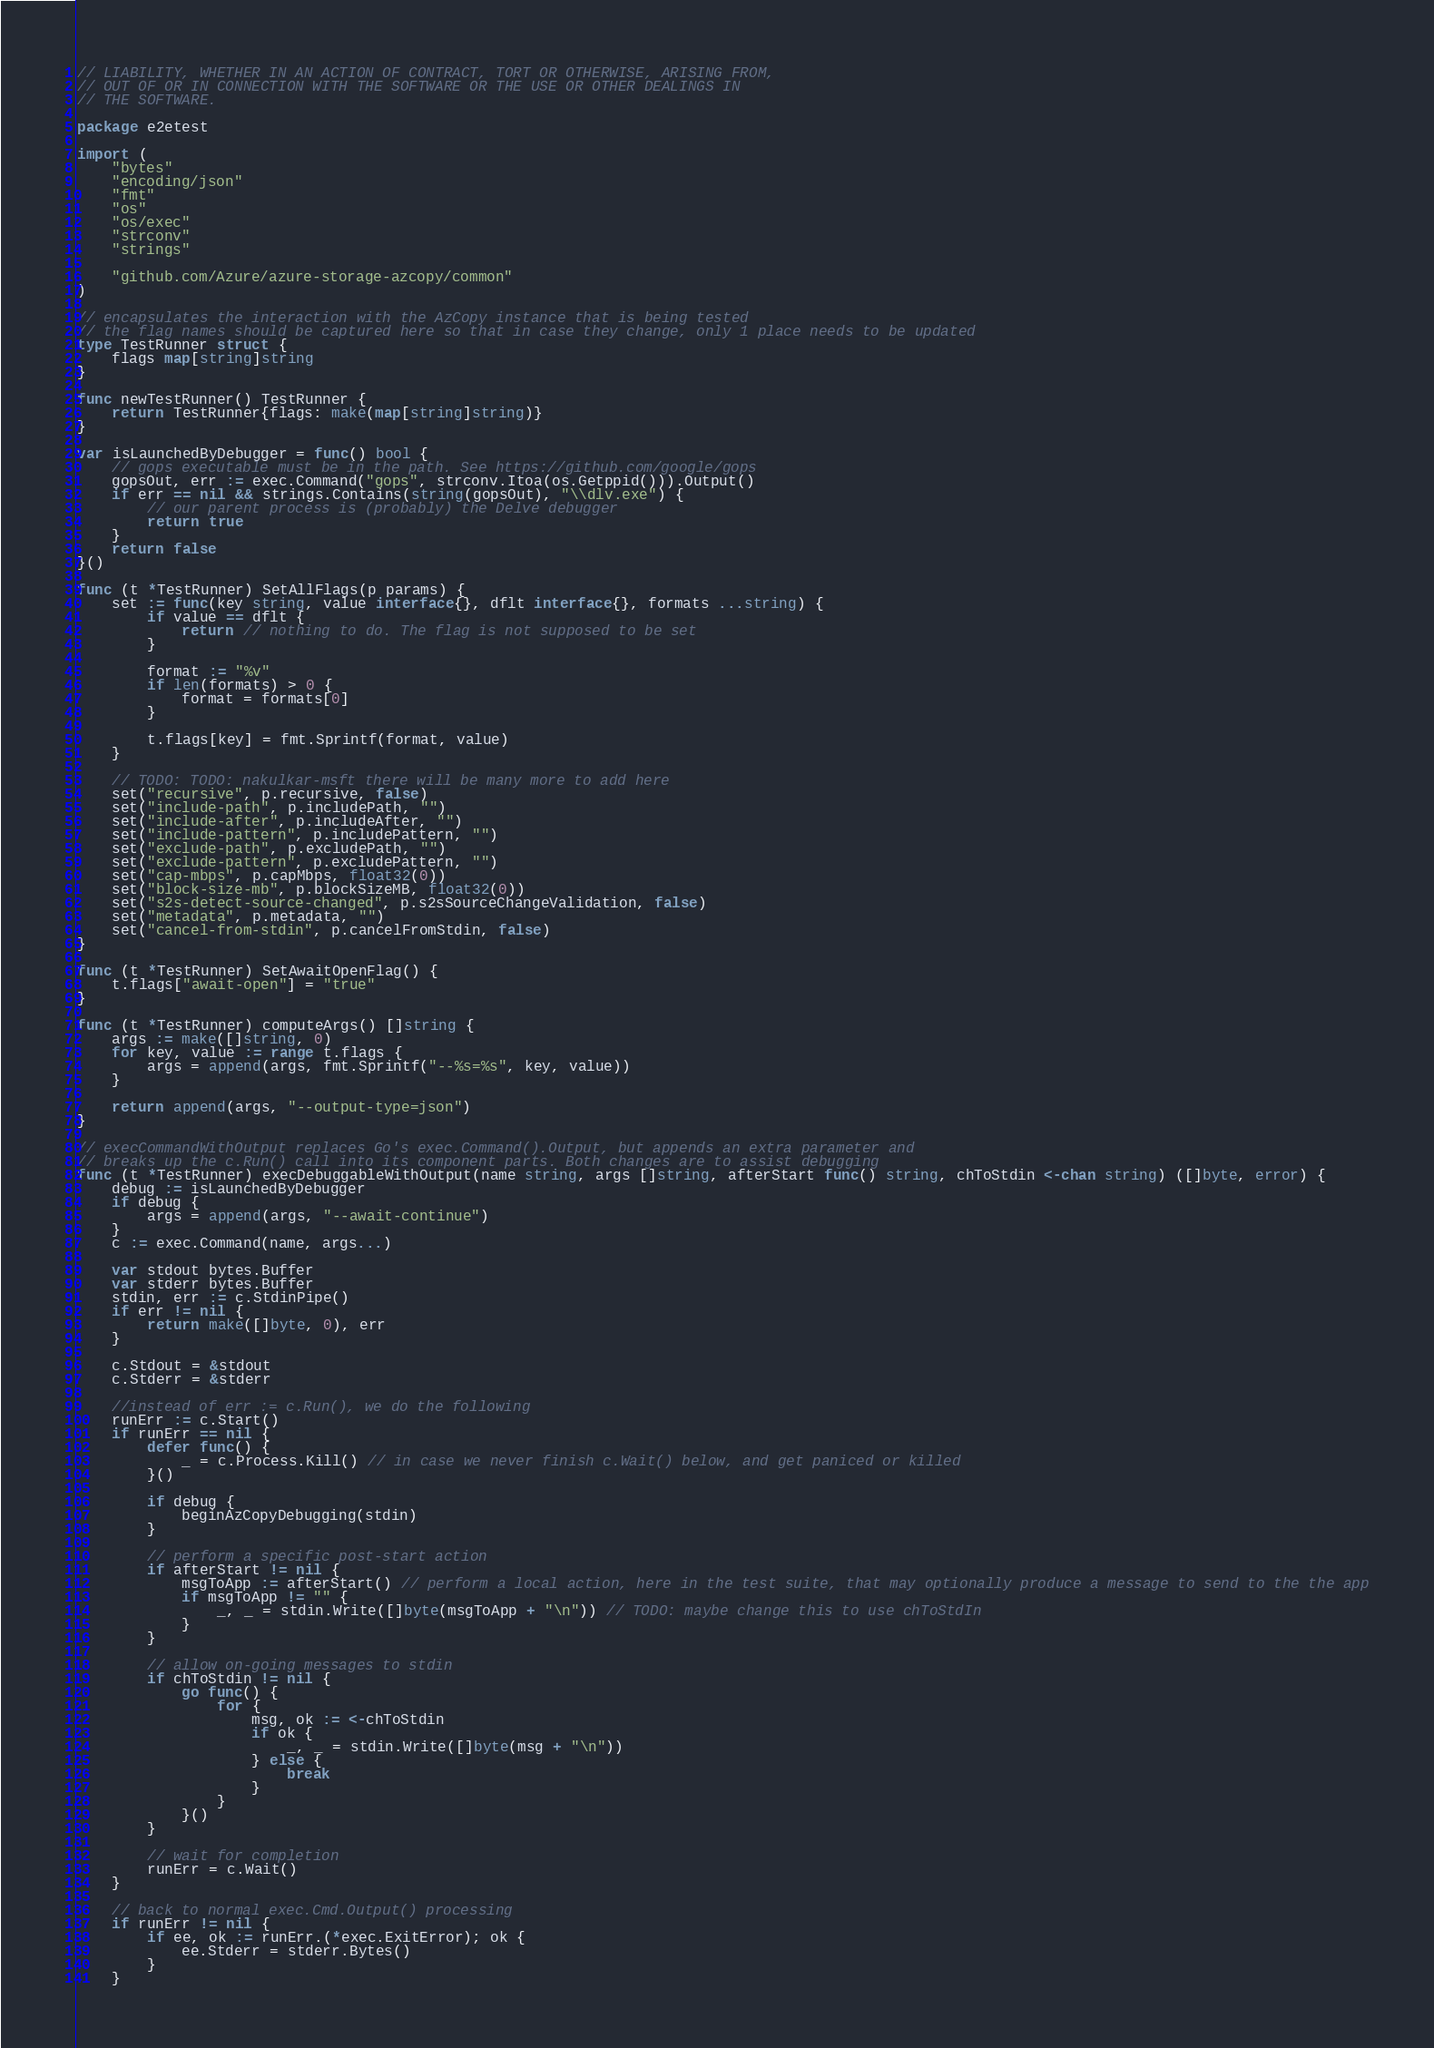Convert code to text. <code><loc_0><loc_0><loc_500><loc_500><_Go_>// LIABILITY, WHETHER IN AN ACTION OF CONTRACT, TORT OR OTHERWISE, ARISING FROM,
// OUT OF OR IN CONNECTION WITH THE SOFTWARE OR THE USE OR OTHER DEALINGS IN
// THE SOFTWARE.

package e2etest

import (
	"bytes"
	"encoding/json"
	"fmt"
	"os"
	"os/exec"
	"strconv"
	"strings"

	"github.com/Azure/azure-storage-azcopy/common"
)

// encapsulates the interaction with the AzCopy instance that is being tested
// the flag names should be captured here so that in case they change, only 1 place needs to be updated
type TestRunner struct {
	flags map[string]string
}

func newTestRunner() TestRunner {
	return TestRunner{flags: make(map[string]string)}
}

var isLaunchedByDebugger = func() bool {
	// gops executable must be in the path. See https://github.com/google/gops
	gopsOut, err := exec.Command("gops", strconv.Itoa(os.Getppid())).Output()
	if err == nil && strings.Contains(string(gopsOut), "\\dlv.exe") {
		// our parent process is (probably) the Delve debugger
		return true
	}
	return false
}()

func (t *TestRunner) SetAllFlags(p params) {
	set := func(key string, value interface{}, dflt interface{}, formats ...string) {
		if value == dflt {
			return // nothing to do. The flag is not supposed to be set
		}

		format := "%v"
		if len(formats) > 0 {
			format = formats[0]
		}

		t.flags[key] = fmt.Sprintf(format, value)
	}

	// TODO: TODO: nakulkar-msft there will be many more to add here
	set("recursive", p.recursive, false)
	set("include-path", p.includePath, "")
	set("include-after", p.includeAfter, "")
	set("include-pattern", p.includePattern, "")
	set("exclude-path", p.excludePath, "")
	set("exclude-pattern", p.excludePattern, "")
	set("cap-mbps", p.capMbps, float32(0))
	set("block-size-mb", p.blockSizeMB, float32(0))
	set("s2s-detect-source-changed", p.s2sSourceChangeValidation, false)
	set("metadata", p.metadata, "")
	set("cancel-from-stdin", p.cancelFromStdin, false)
}

func (t *TestRunner) SetAwaitOpenFlag() {
	t.flags["await-open"] = "true"
}

func (t *TestRunner) computeArgs() []string {
	args := make([]string, 0)
	for key, value := range t.flags {
		args = append(args, fmt.Sprintf("--%s=%s", key, value))
	}

	return append(args, "--output-type=json")
}

// execCommandWithOutput replaces Go's exec.Command().Output, but appends an extra parameter and
// breaks up the c.Run() call into its component parts. Both changes are to assist debugging
func (t *TestRunner) execDebuggableWithOutput(name string, args []string, afterStart func() string, chToStdin <-chan string) ([]byte, error) {
	debug := isLaunchedByDebugger
	if debug {
		args = append(args, "--await-continue")
	}
	c := exec.Command(name, args...)

	var stdout bytes.Buffer
	var stderr bytes.Buffer
	stdin, err := c.StdinPipe()
	if err != nil {
		return make([]byte, 0), err
	}

	c.Stdout = &stdout
	c.Stderr = &stderr

	//instead of err := c.Run(), we do the following
	runErr := c.Start()
	if runErr == nil {
		defer func() {
			_ = c.Process.Kill() // in case we never finish c.Wait() below, and get paniced or killed
		}()

		if debug {
			beginAzCopyDebugging(stdin)
		}

		// perform a specific post-start action
		if afterStart != nil {
			msgToApp := afterStart() // perform a local action, here in the test suite, that may optionally produce a message to send to the the app
			if msgToApp != "" {
				_, _ = stdin.Write([]byte(msgToApp + "\n")) // TODO: maybe change this to use chToStdIn
			}
		}

		// allow on-going messages to stdin
		if chToStdin != nil {
			go func() {
				for {
					msg, ok := <-chToStdin
					if ok {
						_, _ = stdin.Write([]byte(msg + "\n"))
					} else {
						break
					}
				}
			}()
		}

		// wait for completion
		runErr = c.Wait()
	}

	// back to normal exec.Cmd.Output() processing
	if runErr != nil {
		if ee, ok := runErr.(*exec.ExitError); ok {
			ee.Stderr = stderr.Bytes()
		}
	}</code> 